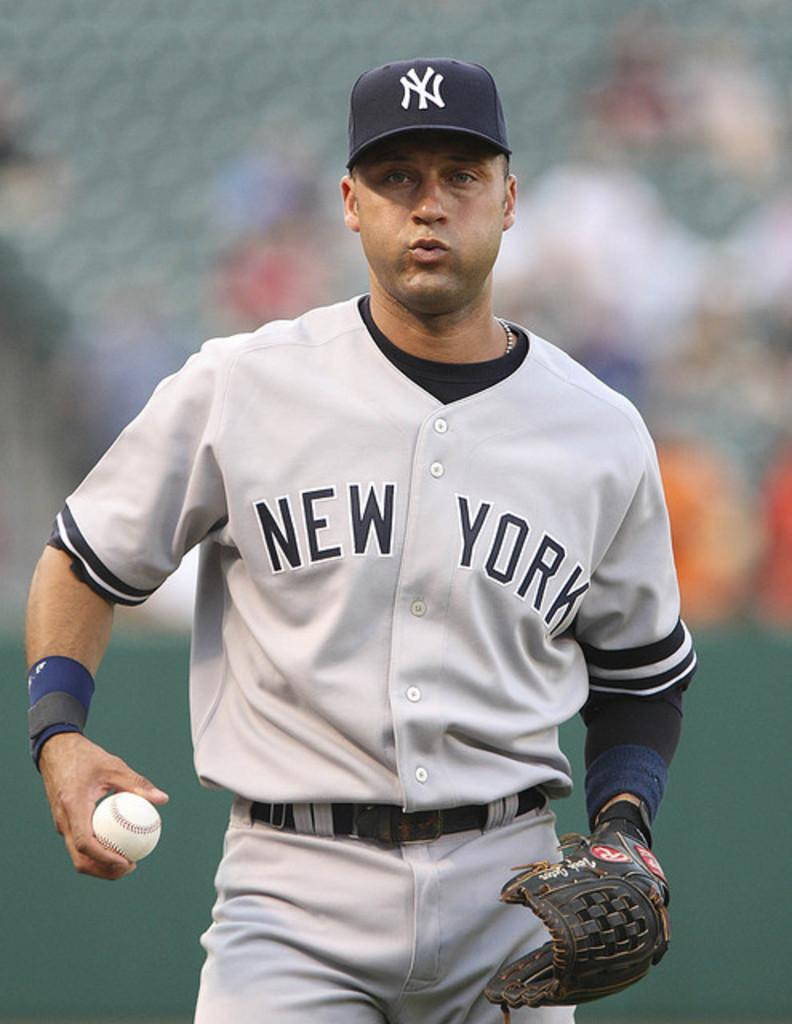Provide a one-sentence caption for the provided image. A player from the New York Yankees baseball team holding a baseball. 